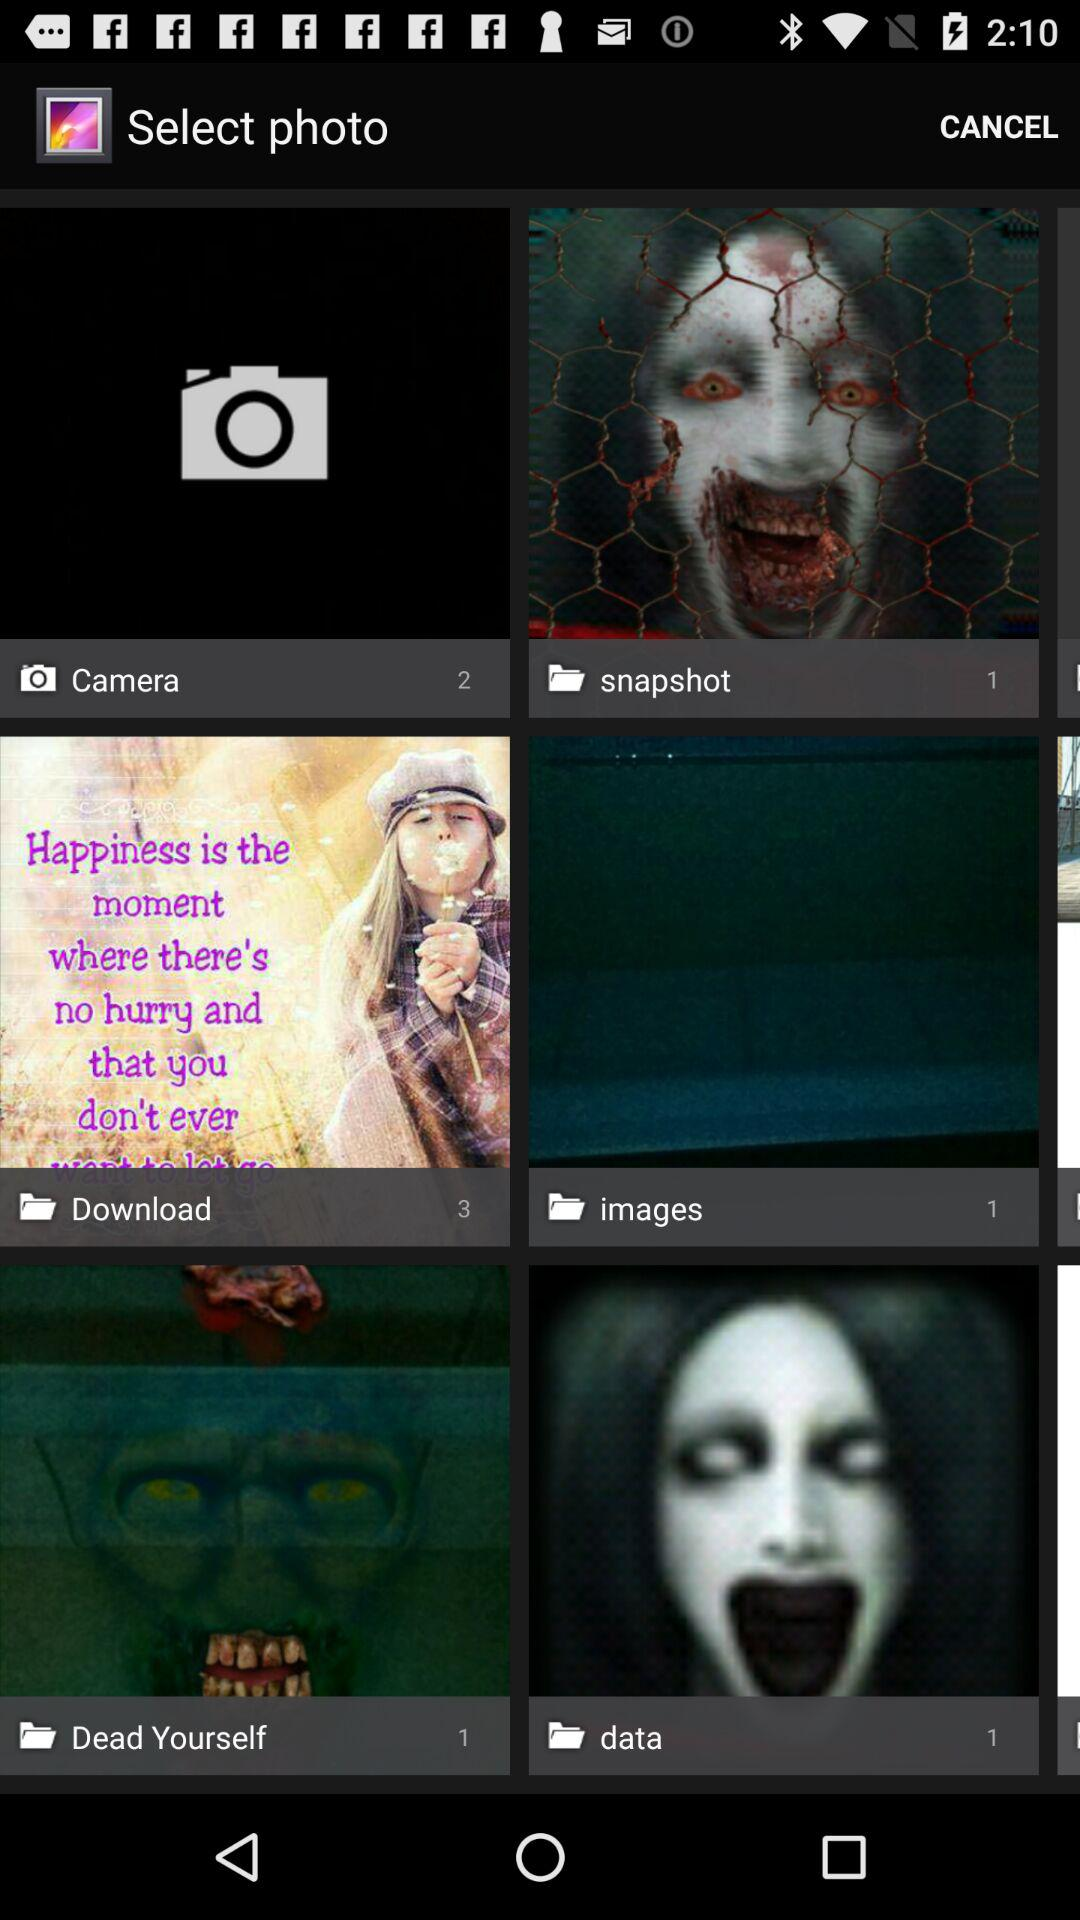What is the number of photos in the "data" folder? The number of photos in the "data" folder is 1. 